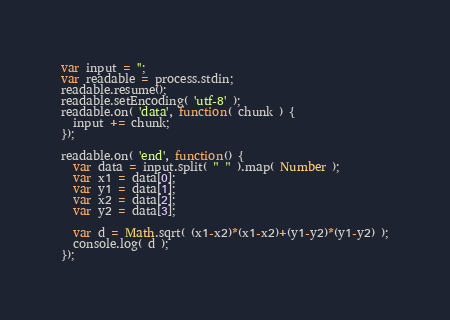<code> <loc_0><loc_0><loc_500><loc_500><_JavaScript_>var input = '';
var readable = process.stdin;
readable.resume();
readable.setEncoding( 'utf-8' );
readable.on( 'data', function( chunk ) {
  input += chunk;
});

readable.on( 'end', function() {
  var data = input.split( " " ).map( Number );
  var x1 = data[0];
  var y1 = data[1];
  var x2 = data[2];
  var y2 = data[3];
  
  var d = Math.sqrt( (x1-x2)*(x1-x2)+(y1-y2)*(y1-y2) );
  console.log( d );
});</code> 